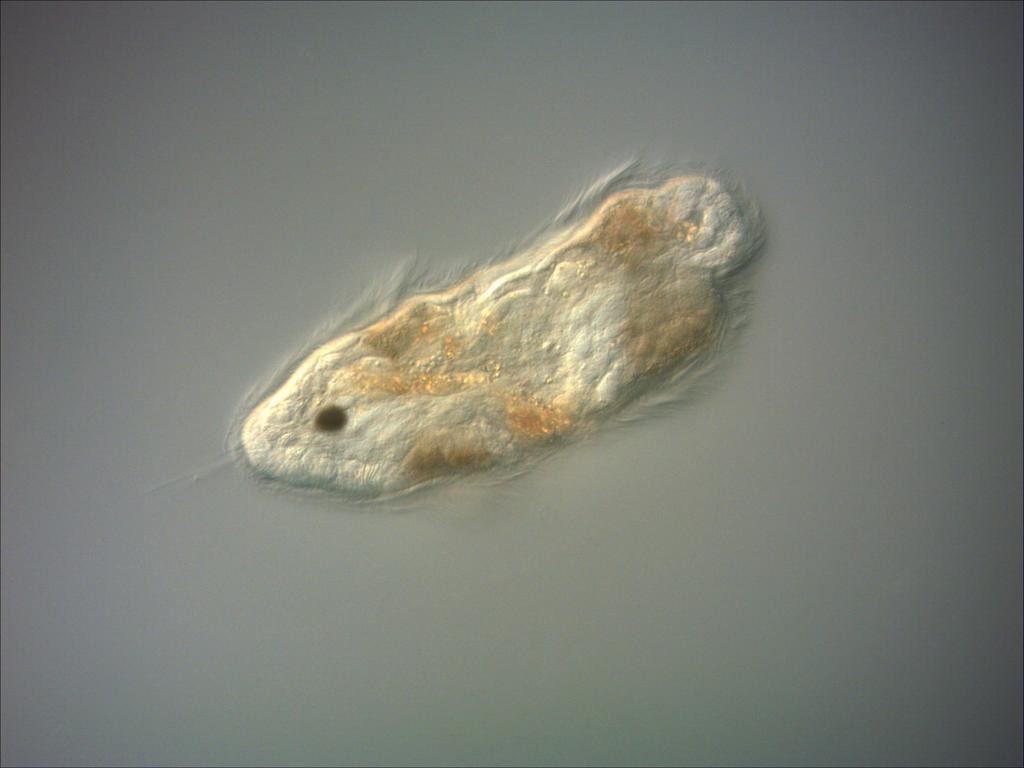What is the focus of the image? The image is zoomed in, and there is an object in the center of the image. Can you describe the object in the center of the image? The object appears to be an insect. What letters can be seen on the insect's back in the image? There are no letters visible on the insect's back in the image. How does the insect slip on the surface in the image? There is no indication of the insect slipping on any surface in the image. 